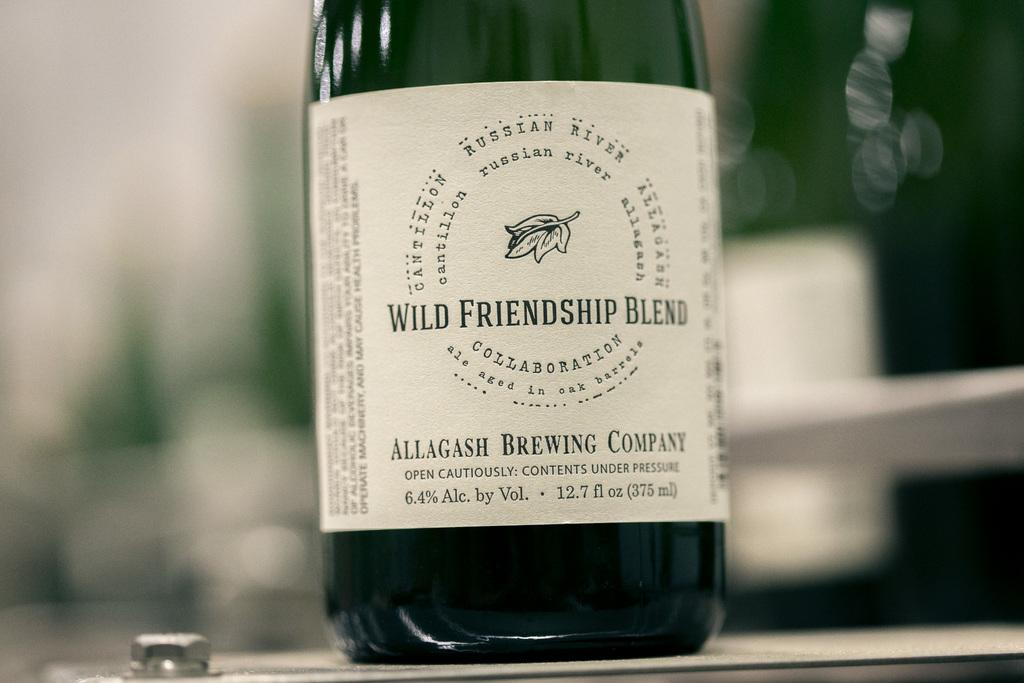Provide a one-sentence caption for the provided image. bottle of wine called wild friendship blend sits un opened. 